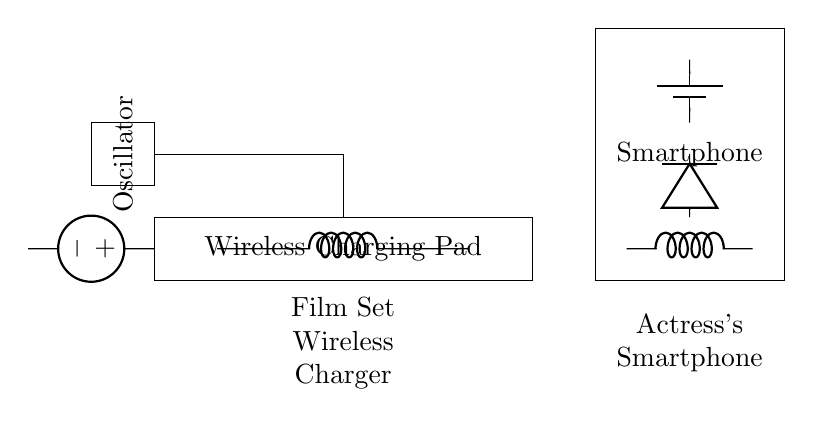What is the component that converts AC to DC? The rectifier, which is represented by the diode, converts alternating current (AC) generated by the receiver coil into direct current (DC) for the battery.
Answer: diode What powers the wireless charging pad? The power source, which is an American voltage source, supplies electrical energy to the wireless charging pad for operation.
Answer: American voltage source What type of circuit is illustrated? This is a wireless charging circuit, designed specifically for charging a smartphone without physical connections using electromagnetic induction.
Answer: wireless charging circuit How many coils are present in the circuit? There are two coils in the circuit: one transmitter coil in the charging pad and one receiver coil in the smartphone.
Answer: two What is the purpose of the oscillator in the circuit? The oscillator generates an alternating current at a specific frequency to create a magnetic field used for transfer in wireless charging.
Answer: generate AC What is the battery's role in the circuit? The battery stores the direct current produced by the rectifier, supplying power to the smartphone after charging is complete.
Answer: store energy What is the connection between the receiver coil and the battery? The receiver coil is connected to the rectifier, which then connects to the battery; this process allows the battery to be charged using the DC output from the rectifier.
Answer: rectifier connection 